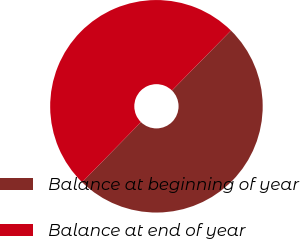<chart> <loc_0><loc_0><loc_500><loc_500><pie_chart><fcel>Balance at beginning of year<fcel>Balance at end of year<nl><fcel>49.96%<fcel>50.04%<nl></chart> 